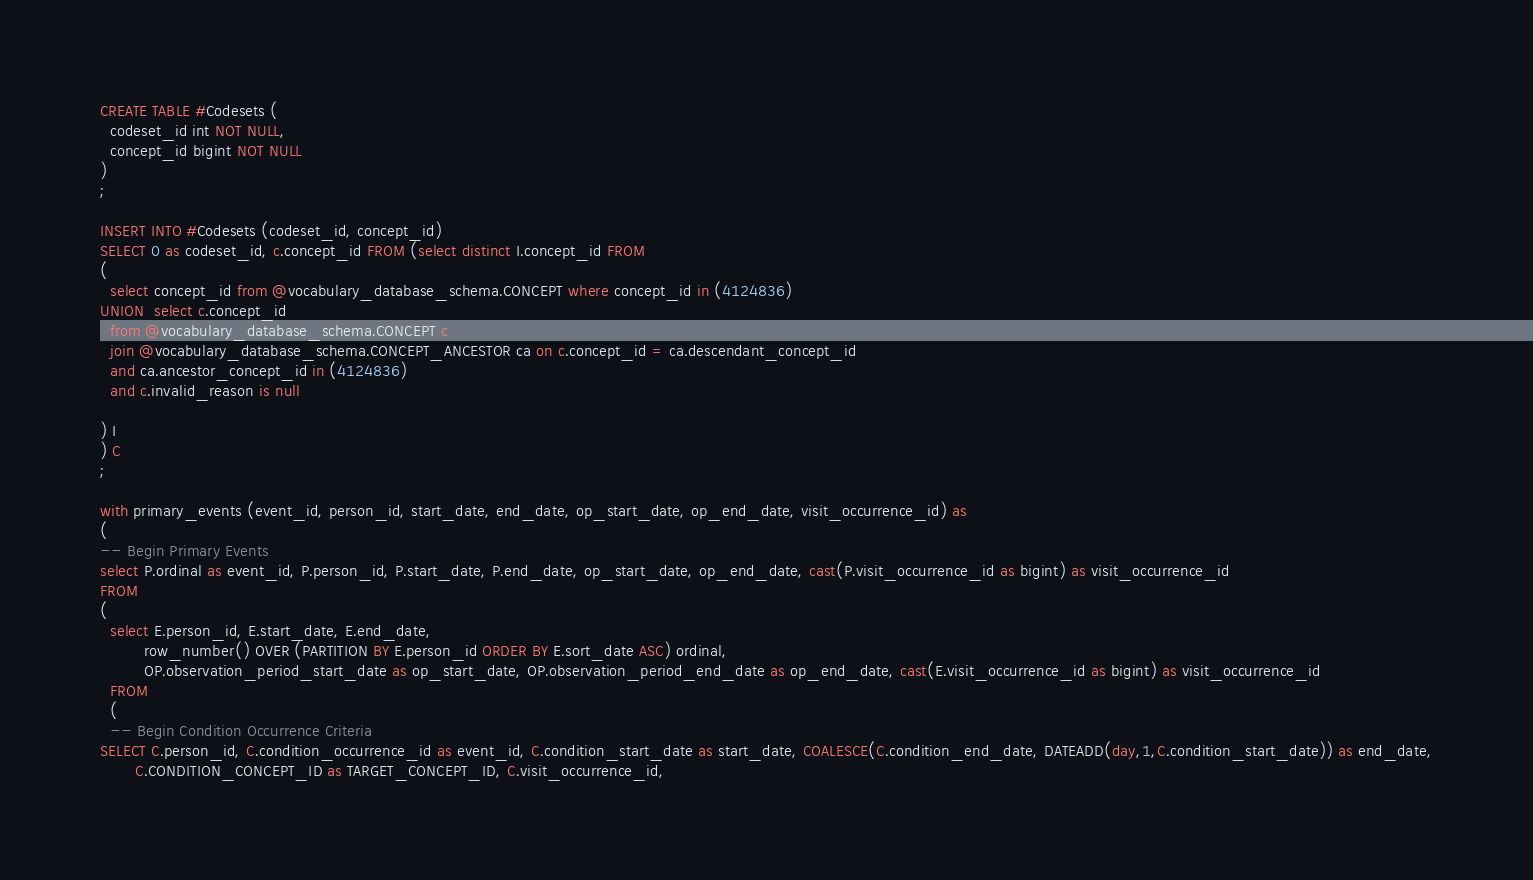<code> <loc_0><loc_0><loc_500><loc_500><_SQL_>CREATE TABLE #Codesets (
  codeset_id int NOT NULL,
  concept_id bigint NOT NULL
)
;

INSERT INTO #Codesets (codeset_id, concept_id)
SELECT 0 as codeset_id, c.concept_id FROM (select distinct I.concept_id FROM
( 
  select concept_id from @vocabulary_database_schema.CONCEPT where concept_id in (4124836)
UNION  select c.concept_id
  from @vocabulary_database_schema.CONCEPT c
  join @vocabulary_database_schema.CONCEPT_ANCESTOR ca on c.concept_id = ca.descendant_concept_id
  and ca.ancestor_concept_id in (4124836)
  and c.invalid_reason is null

) I
) C
;

with primary_events (event_id, person_id, start_date, end_date, op_start_date, op_end_date, visit_occurrence_id) as
(
-- Begin Primary Events
select P.ordinal as event_id, P.person_id, P.start_date, P.end_date, op_start_date, op_end_date, cast(P.visit_occurrence_id as bigint) as visit_occurrence_id
FROM
(
  select E.person_id, E.start_date, E.end_date,
         row_number() OVER (PARTITION BY E.person_id ORDER BY E.sort_date ASC) ordinal,
         OP.observation_period_start_date as op_start_date, OP.observation_period_end_date as op_end_date, cast(E.visit_occurrence_id as bigint) as visit_occurrence_id
  FROM 
  (
  -- Begin Condition Occurrence Criteria
SELECT C.person_id, C.condition_occurrence_id as event_id, C.condition_start_date as start_date, COALESCE(C.condition_end_date, DATEADD(day,1,C.condition_start_date)) as end_date,
       C.CONDITION_CONCEPT_ID as TARGET_CONCEPT_ID, C.visit_occurrence_id,</code> 